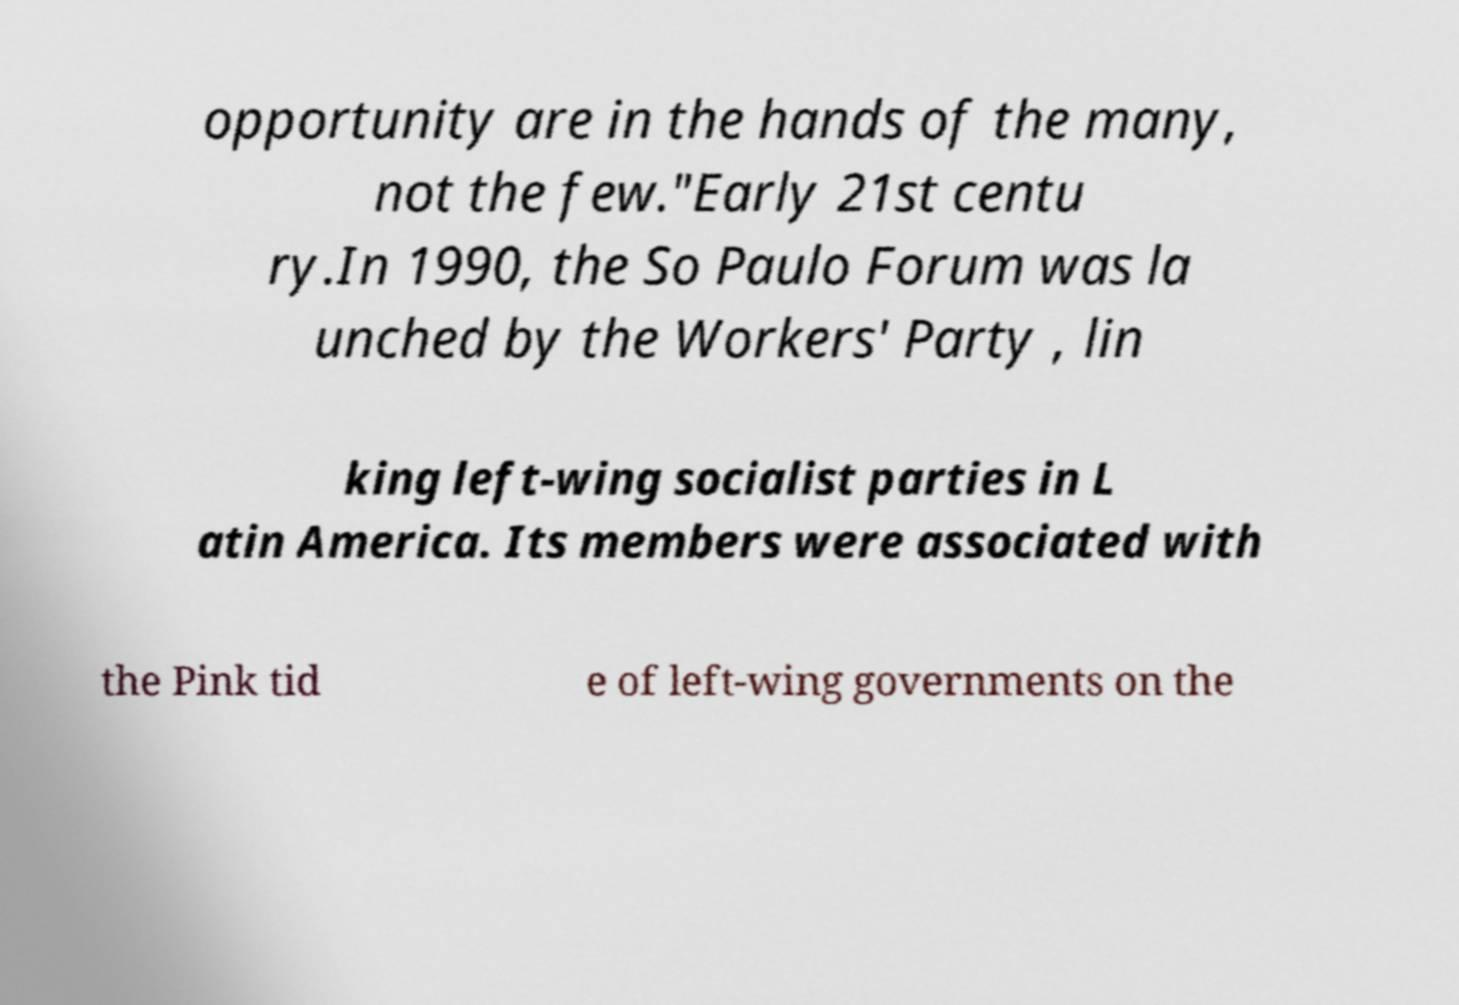There's text embedded in this image that I need extracted. Can you transcribe it verbatim? opportunity are in the hands of the many, not the few."Early 21st centu ry.In 1990, the So Paulo Forum was la unched by the Workers' Party , lin king left-wing socialist parties in L atin America. Its members were associated with the Pink tid e of left-wing governments on the 